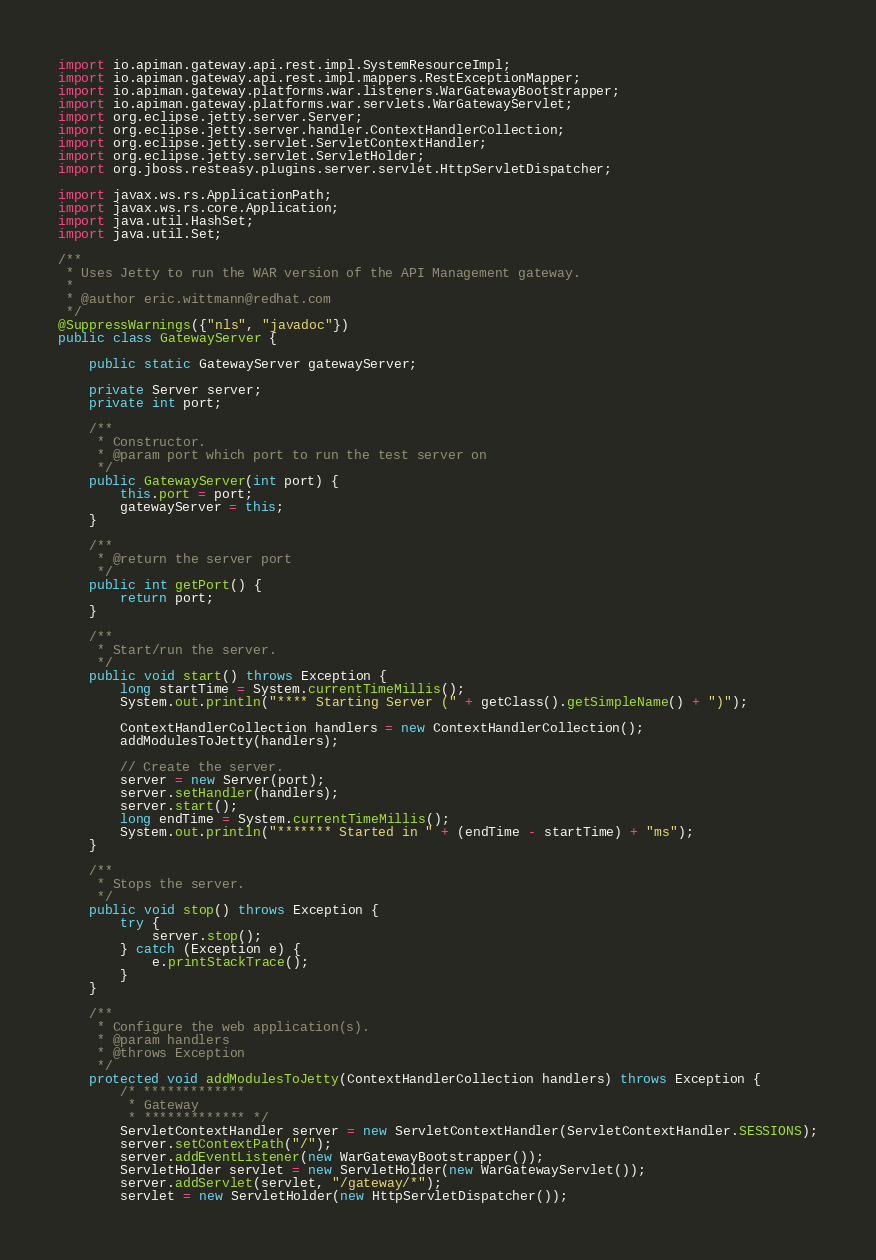Convert code to text. <code><loc_0><loc_0><loc_500><loc_500><_Java_>import io.apiman.gateway.api.rest.impl.SystemResourceImpl;
import io.apiman.gateway.api.rest.impl.mappers.RestExceptionMapper;
import io.apiman.gateway.platforms.war.listeners.WarGatewayBootstrapper;
import io.apiman.gateway.platforms.war.servlets.WarGatewayServlet;
import org.eclipse.jetty.server.Server;
import org.eclipse.jetty.server.handler.ContextHandlerCollection;
import org.eclipse.jetty.servlet.ServletContextHandler;
import org.eclipse.jetty.servlet.ServletHolder;
import org.jboss.resteasy.plugins.server.servlet.HttpServletDispatcher;

import javax.ws.rs.ApplicationPath;
import javax.ws.rs.core.Application;
import java.util.HashSet;
import java.util.Set;

/**
 * Uses Jetty to run the WAR version of the API Management gateway.
 *
 * @author eric.wittmann@redhat.com
 */
@SuppressWarnings({"nls", "javadoc"})
public class GatewayServer {

    public static GatewayServer gatewayServer;

    private Server server;
    private int port;

    /**
     * Constructor.
     * @param port which port to run the test server on
     */
    public GatewayServer(int port) {
        this.port = port;
        gatewayServer = this;
    }

    /**
     * @return the server port
     */
    public int getPort() {
        return port;
    }

    /**
     * Start/run the server.
     */
    public void start() throws Exception {
        long startTime = System.currentTimeMillis();
        System.out.println("**** Starting Server (" + getClass().getSimpleName() + ")");

        ContextHandlerCollection handlers = new ContextHandlerCollection();
        addModulesToJetty(handlers);

        // Create the server.
        server = new Server(port);
        server.setHandler(handlers);
        server.start();
        long endTime = System.currentTimeMillis();
        System.out.println("******* Started in " + (endTime - startTime) + "ms");
    }

    /**
     * Stops the server.
     */
    public void stop() throws Exception {
        try {
            server.stop();
        } catch (Exception e) {
            e.printStackTrace();
        }
    }

    /**
     * Configure the web application(s).
     * @param handlers
     * @throws Exception
     */
    protected void addModulesToJetty(ContextHandlerCollection handlers) throws Exception {
        /* *************
         * Gateway
         * ************* */
        ServletContextHandler server = new ServletContextHandler(ServletContextHandler.SESSIONS);
        server.setContextPath("/");
        server.addEventListener(new WarGatewayBootstrapper());
        ServletHolder servlet = new ServletHolder(new WarGatewayServlet());
        server.addServlet(servlet, "/gateway/*");
        servlet = new ServletHolder(new HttpServletDispatcher());</code> 